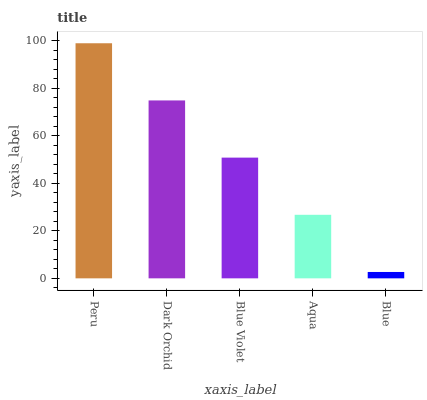Is Dark Orchid the minimum?
Answer yes or no. No. Is Dark Orchid the maximum?
Answer yes or no. No. Is Peru greater than Dark Orchid?
Answer yes or no. Yes. Is Dark Orchid less than Peru?
Answer yes or no. Yes. Is Dark Orchid greater than Peru?
Answer yes or no. No. Is Peru less than Dark Orchid?
Answer yes or no. No. Is Blue Violet the high median?
Answer yes or no. Yes. Is Blue Violet the low median?
Answer yes or no. Yes. Is Peru the high median?
Answer yes or no. No. Is Aqua the low median?
Answer yes or no. No. 